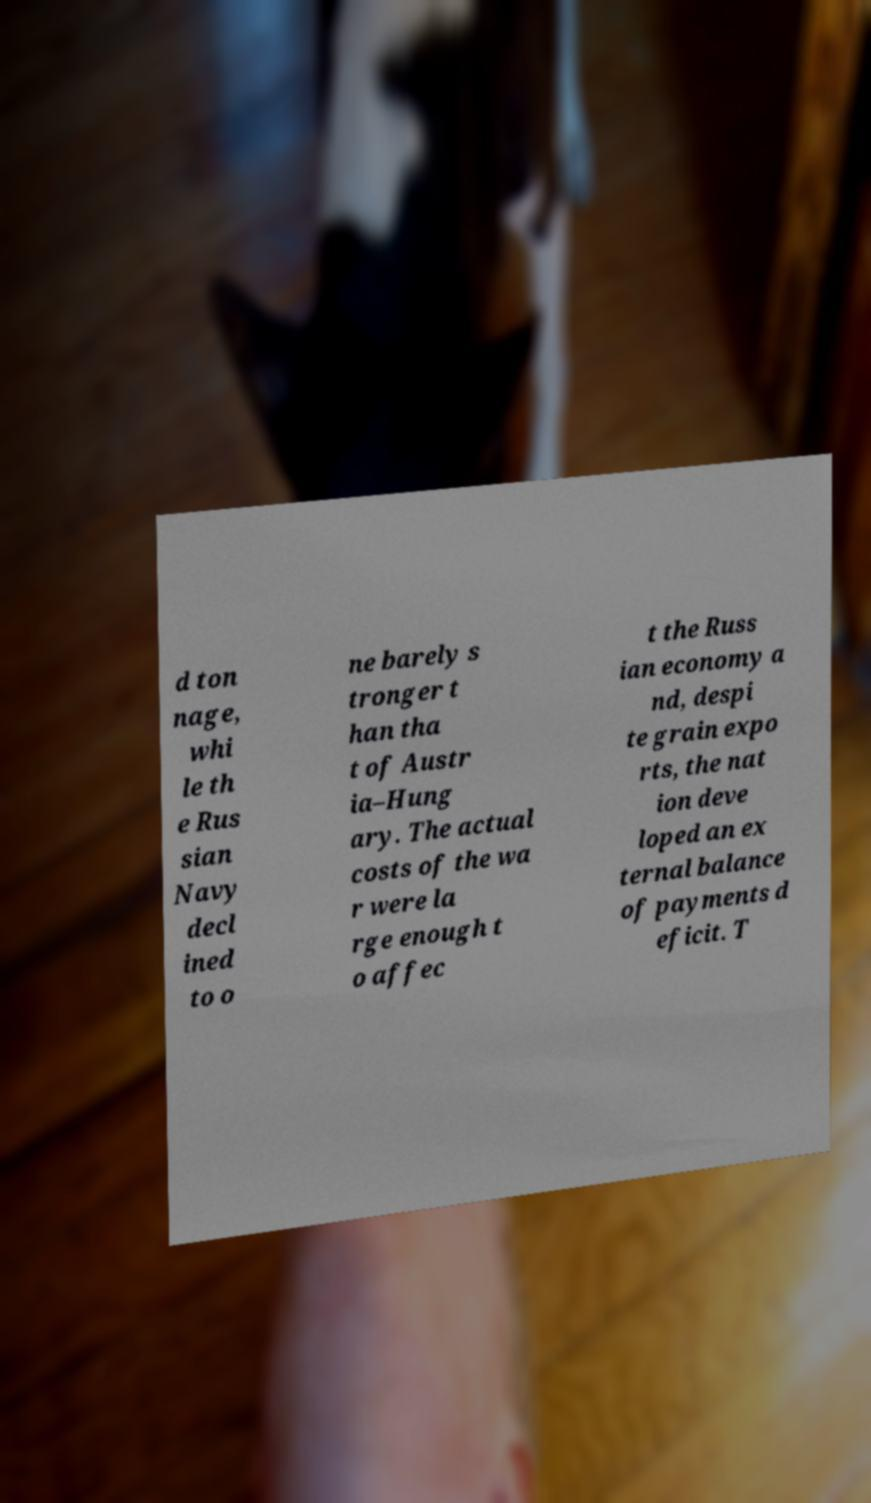Can you read and provide the text displayed in the image?This photo seems to have some interesting text. Can you extract and type it out for me? d ton nage, whi le th e Rus sian Navy decl ined to o ne barely s tronger t han tha t of Austr ia–Hung ary. The actual costs of the wa r were la rge enough t o affec t the Russ ian economy a nd, despi te grain expo rts, the nat ion deve loped an ex ternal balance of payments d eficit. T 